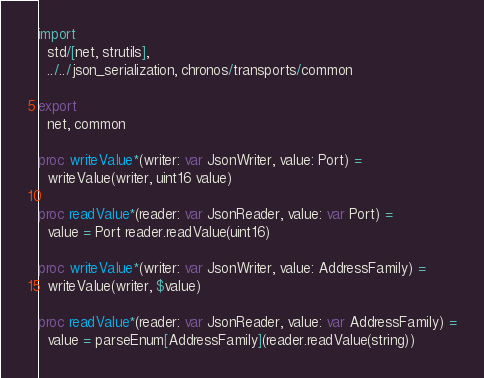<code> <loc_0><loc_0><loc_500><loc_500><_Nim_>import
  std/[net, strutils],
  ../../json_serialization, chronos/transports/common

export
  net, common

proc writeValue*(writer: var JsonWriter, value: Port) =
  writeValue(writer, uint16 value)

proc readValue*(reader: var JsonReader, value: var Port) =
  value = Port reader.readValue(uint16)

proc writeValue*(writer: var JsonWriter, value: AddressFamily) =
  writeValue(writer, $value)

proc readValue*(reader: var JsonReader, value: var AddressFamily) =
  value = parseEnum[AddressFamily](reader.readValue(string))

</code> 